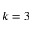Convert formula to latex. <formula><loc_0><loc_0><loc_500><loc_500>k = 3</formula> 